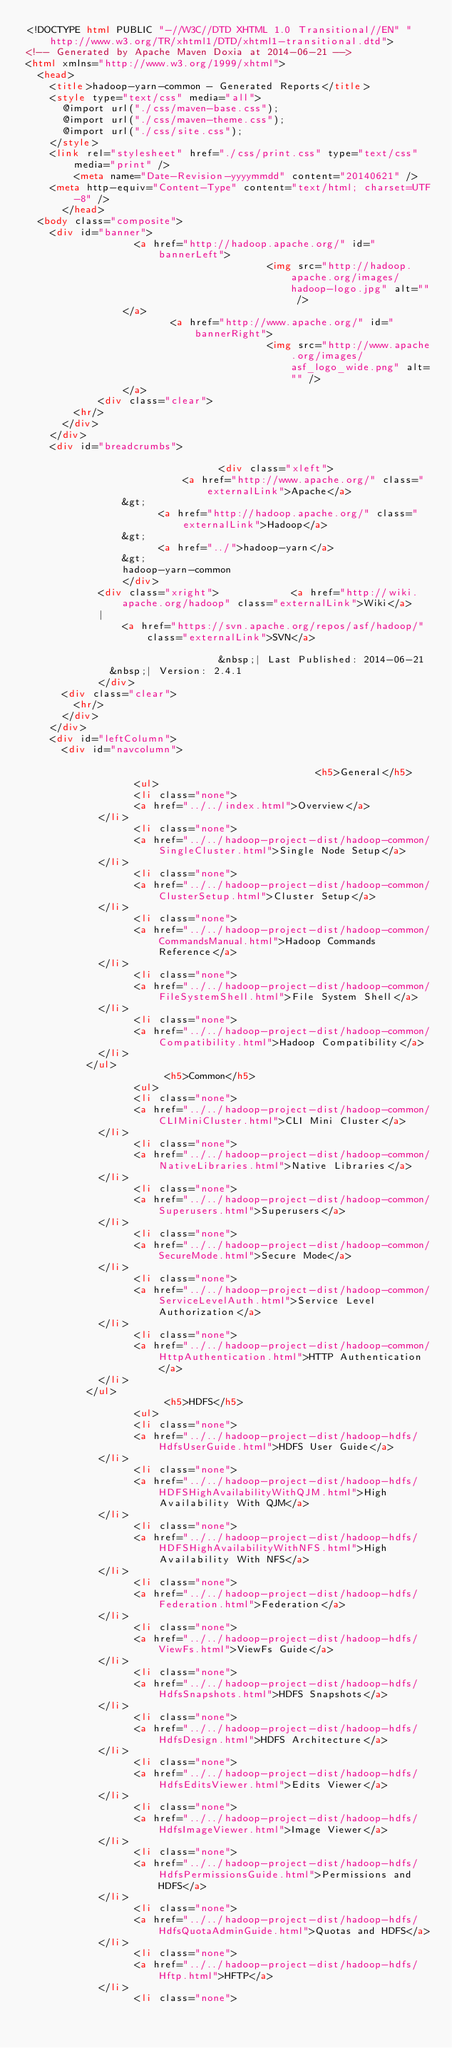Convert code to text. <code><loc_0><loc_0><loc_500><loc_500><_HTML_><!DOCTYPE html PUBLIC "-//W3C//DTD XHTML 1.0 Transitional//EN" "http://www.w3.org/TR/xhtml1/DTD/xhtml1-transitional.dtd">
<!-- Generated by Apache Maven Doxia at 2014-06-21 -->
<html xmlns="http://www.w3.org/1999/xhtml">
  <head>
    <title>hadoop-yarn-common - Generated Reports</title>
    <style type="text/css" media="all">
      @import url("./css/maven-base.css");
      @import url("./css/maven-theme.css");
      @import url("./css/site.css");
    </style>
    <link rel="stylesheet" href="./css/print.css" type="text/css" media="print" />
        <meta name="Date-Revision-yyyymmdd" content="20140621" />
    <meta http-equiv="Content-Type" content="text/html; charset=UTF-8" />
      </head>
  <body class="composite">
    <div id="banner">
                  <a href="http://hadoop.apache.org/" id="bannerLeft">
                                        <img src="http://hadoop.apache.org/images/hadoop-logo.jpg" alt="" />
                </a>
                        <a href="http://www.apache.org/" id="bannerRight">
                                        <img src="http://www.apache.org/images/asf_logo_wide.png" alt="" />
                </a>
            <div class="clear">
        <hr/>
      </div>
    </div>
    <div id="breadcrumbs">
            
                                <div class="xleft">
                          <a href="http://www.apache.org/" class="externalLink">Apache</a>
                &gt;
                      <a href="http://hadoop.apache.org/" class="externalLink">Hadoop</a>
                &gt;
                      <a href="../">hadoop-yarn</a>
                &gt;
                hadoop-yarn-common
                </div>
            <div class="xright">            <a href="http://wiki.apache.org/hadoop" class="externalLink">Wiki</a>
            |
                <a href="https://svn.apache.org/repos/asf/hadoop/" class="externalLink">SVN</a>
              
                                &nbsp;| Last Published: 2014-06-21
              &nbsp;| Version: 2.4.1
            </div>
      <div class="clear">
        <hr/>
      </div>
    </div>
    <div id="leftColumn">
      <div id="navcolumn">
             
                                                <h5>General</h5>
                  <ul>
                  <li class="none">
                  <a href="../../index.html">Overview</a>
            </li>
                  <li class="none">
                  <a href="../../hadoop-project-dist/hadoop-common/SingleCluster.html">Single Node Setup</a>
            </li>
                  <li class="none">
                  <a href="../../hadoop-project-dist/hadoop-common/ClusterSetup.html">Cluster Setup</a>
            </li>
                  <li class="none">
                  <a href="../../hadoop-project-dist/hadoop-common/CommandsManual.html">Hadoop Commands Reference</a>
            </li>
                  <li class="none">
                  <a href="../../hadoop-project-dist/hadoop-common/FileSystemShell.html">File System Shell</a>
            </li>
                  <li class="none">
                  <a href="../../hadoop-project-dist/hadoop-common/Compatibility.html">Hadoop Compatibility</a>
            </li>
          </ul>
                       <h5>Common</h5>
                  <ul>
                  <li class="none">
                  <a href="../../hadoop-project-dist/hadoop-common/CLIMiniCluster.html">CLI Mini Cluster</a>
            </li>
                  <li class="none">
                  <a href="../../hadoop-project-dist/hadoop-common/NativeLibraries.html">Native Libraries</a>
            </li>
                  <li class="none">
                  <a href="../../hadoop-project-dist/hadoop-common/Superusers.html">Superusers</a>
            </li>
                  <li class="none">
                  <a href="../../hadoop-project-dist/hadoop-common/SecureMode.html">Secure Mode</a>
            </li>
                  <li class="none">
                  <a href="../../hadoop-project-dist/hadoop-common/ServiceLevelAuth.html">Service Level Authorization</a>
            </li>
                  <li class="none">
                  <a href="../../hadoop-project-dist/hadoop-common/HttpAuthentication.html">HTTP Authentication</a>
            </li>
          </ul>
                       <h5>HDFS</h5>
                  <ul>
                  <li class="none">
                  <a href="../../hadoop-project-dist/hadoop-hdfs/HdfsUserGuide.html">HDFS User Guide</a>
            </li>
                  <li class="none">
                  <a href="../../hadoop-project-dist/hadoop-hdfs/HDFSHighAvailabilityWithQJM.html">High Availability With QJM</a>
            </li>
                  <li class="none">
                  <a href="../../hadoop-project-dist/hadoop-hdfs/HDFSHighAvailabilityWithNFS.html">High Availability With NFS</a>
            </li>
                  <li class="none">
                  <a href="../../hadoop-project-dist/hadoop-hdfs/Federation.html">Federation</a>
            </li>
                  <li class="none">
                  <a href="../../hadoop-project-dist/hadoop-hdfs/ViewFs.html">ViewFs Guide</a>
            </li>
                  <li class="none">
                  <a href="../../hadoop-project-dist/hadoop-hdfs/HdfsSnapshots.html">HDFS Snapshots</a>
            </li>
                  <li class="none">
                  <a href="../../hadoop-project-dist/hadoop-hdfs/HdfsDesign.html">HDFS Architecture</a>
            </li>
                  <li class="none">
                  <a href="../../hadoop-project-dist/hadoop-hdfs/HdfsEditsViewer.html">Edits Viewer</a>
            </li>
                  <li class="none">
                  <a href="../../hadoop-project-dist/hadoop-hdfs/HdfsImageViewer.html">Image Viewer</a>
            </li>
                  <li class="none">
                  <a href="../../hadoop-project-dist/hadoop-hdfs/HdfsPermissionsGuide.html">Permissions and HDFS</a>
            </li>
                  <li class="none">
                  <a href="../../hadoop-project-dist/hadoop-hdfs/HdfsQuotaAdminGuide.html">Quotas and HDFS</a>
            </li>
                  <li class="none">
                  <a href="../../hadoop-project-dist/hadoop-hdfs/Hftp.html">HFTP</a>
            </li>
                  <li class="none"></code> 